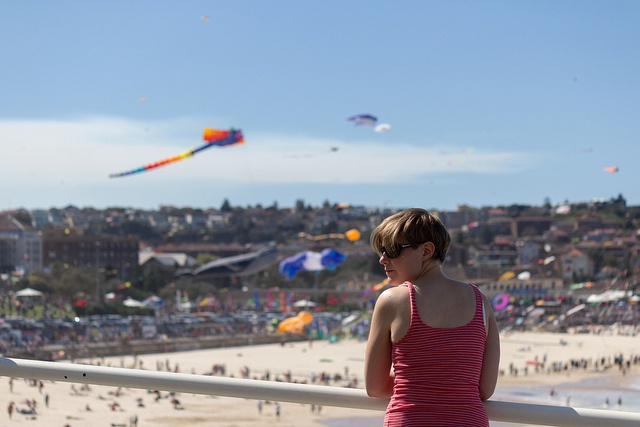Describe the objects in this image and their specific colors. I can see people in lightblue, maroon, gray, black, and purple tones, kite in lightblue, red, lightgray, darkgray, and lightpink tones, kite in lightblue, darkblue, blue, and darkgray tones, kite in lightblue, orange, tan, and gray tones, and kite in lightblue, gray, and orange tones in this image. 